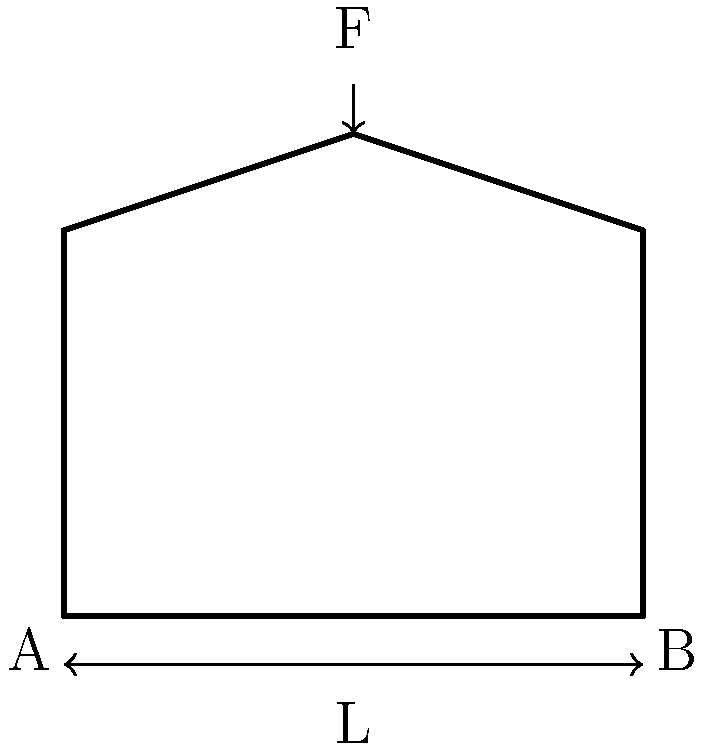A fencing mask is subjected to an impact force F at the top. The mask can be modeled as a curved beam with fixed supports at points A and B, separated by a distance L. If the mask is made of steel with a yield strength of 250 MPa, what is the minimum thickness t of the mask required to withstand an impact force of 1000 N without yielding? Assume the mask has a rectangular cross-section with a width of 30 mm. To solve this problem, we'll follow these steps:

1) The maximum bending moment occurs at the center of the beam:
   $$M_{max} = \frac{FL}{4}$$

2) The section modulus for a rectangular cross-section is:
   $$S = \frac{bt^2}{6}$$
   where b is the width and t is the thickness.

3) The maximum stress in the beam is given by:
   $$\sigma_{max} = \frac{M_{max}}{S}$$

4) We want this stress to be equal to the yield strength:
   $$\sigma_{y} = \frac{M_{max}}{S} = \frac{FL}{4} \cdot \frac{6}{bt^2}$$

5) Solving for t:
   $$t = \sqrt{\frac{3FL}{2b\sigma_{y}}}$$

6) Given:
   F = 1000 N
   L = 0.2 m (estimated from a typical mask size)
   b = 30 mm = 0.03 m
   $\sigma_{y}$ = 250 MPa = 250 × 10^6 Pa

7) Substituting these values:
   $$t = \sqrt{\frac{3 \cdot 1000 \cdot 0.2}{2 \cdot 0.03 \cdot 250 \times 10^6}} = 0.00447 \text{ m} = 4.47 \text{ mm}$$

Therefore, the minimum thickness required is approximately 4.47 mm.
Answer: 4.47 mm 